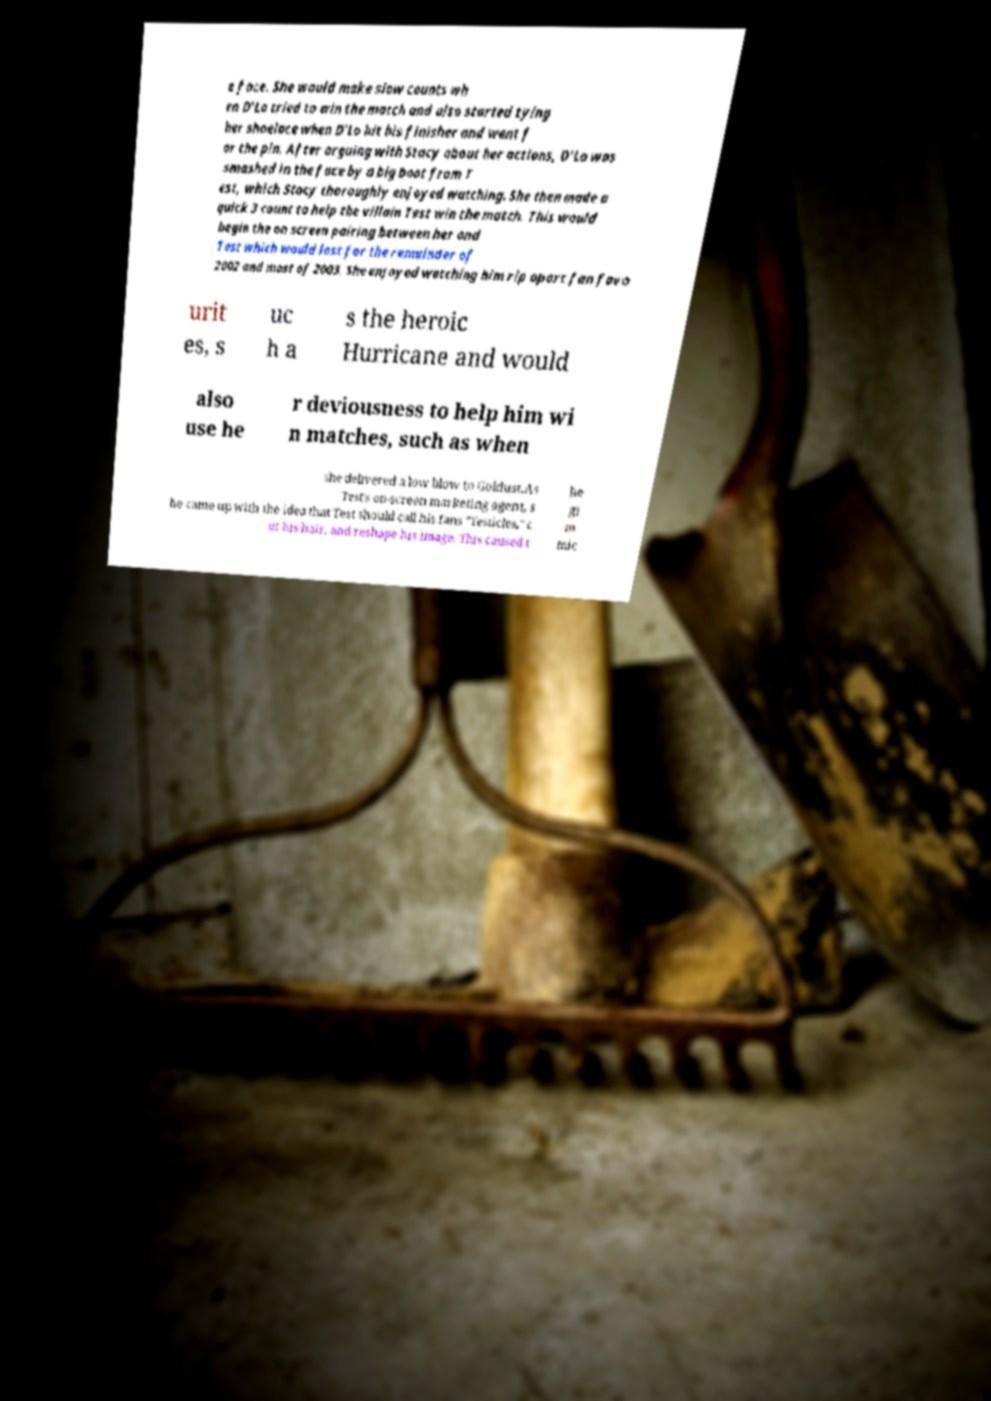There's text embedded in this image that I need extracted. Can you transcribe it verbatim? e face. She would make slow counts wh en D’Lo tried to win the match and also started tying her shoelace when D’Lo hit his finisher and went f or the pin. After arguing with Stacy about her actions, D’Lo was smashed in the face by a big boot from T est, which Stacy thoroughly enjoyed watching. She then made a quick 3 count to help the villain Test win the match. This would begin the on screen pairing between her and Test which would last for the remainder of 2002 and most of 2003. She enjoyed watching him rip apart fan favo urit es, s uc h a s the heroic Hurricane and would also use he r deviousness to help him wi n matches, such as when she delivered a low blow to Goldust.As Test's on-screen marketing agent, s he came up with the idea that Test should call his fans "Testicles," c ut his hair, and reshape his image. This caused t he gi m mic 